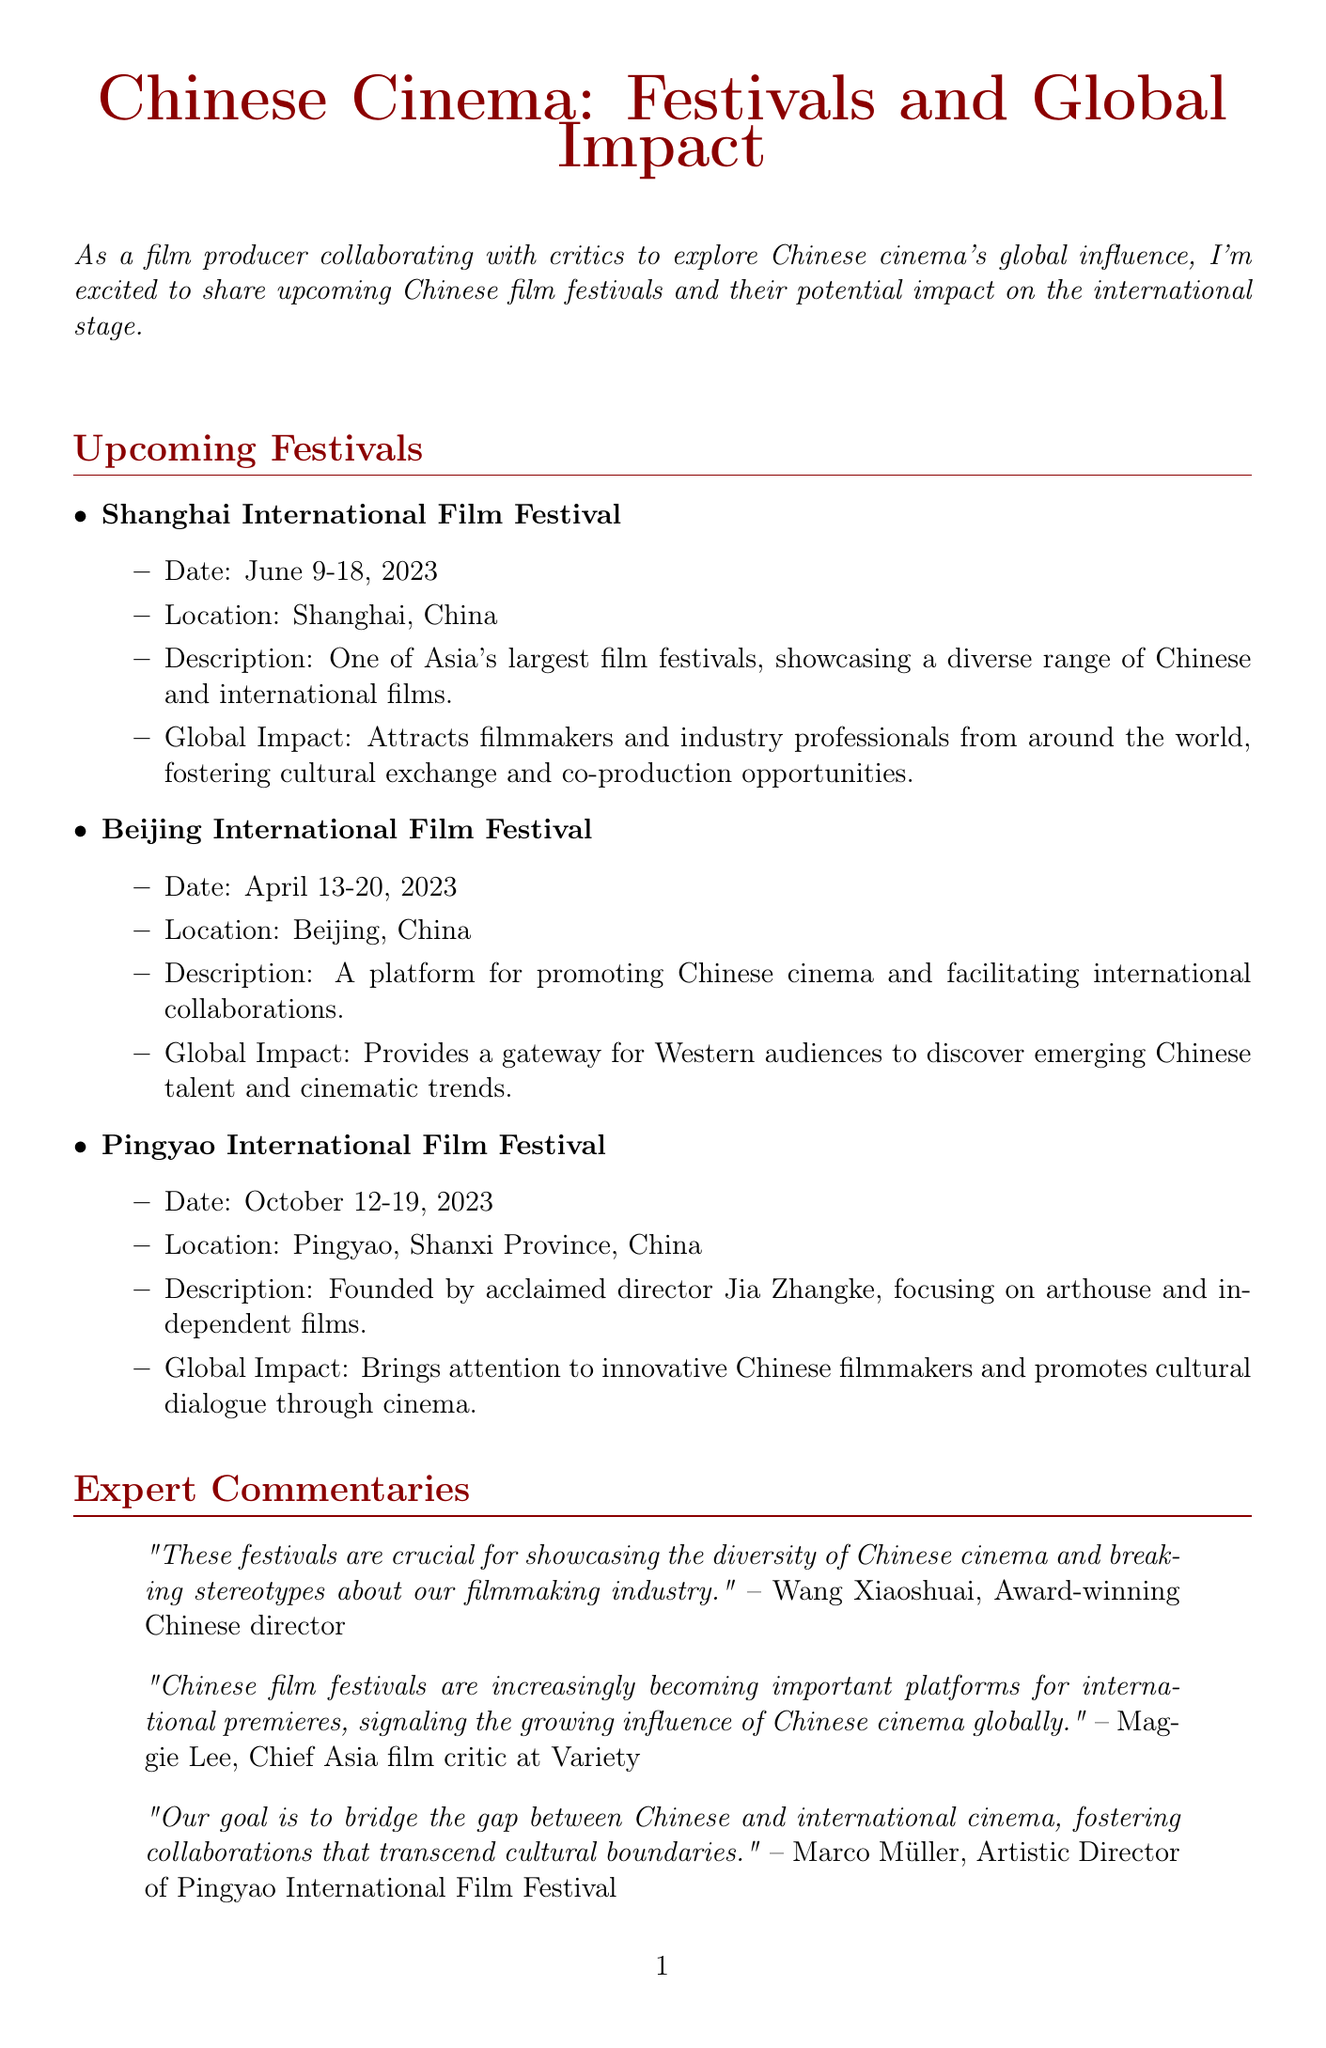What is the name of the festival held in June? The festival held in June is the Shanghai International Film Festival.
Answer: Shanghai International Film Festival What are the dates of the Pingyao International Film Festival? The dates of the Pingyao International Film Festival are October 12-19, 2023.
Answer: October 12-19, 2023 Who is the Chief Asia film critic at Variety? The Chief Asia film critic at Variety is Maggie Lee.
Answer: Maggie Lee What is the main focus of the Pingyao International Film Festival? The main focus of the Pingyao International Film Festival is arthouse and independent films.
Answer: Arthouse and independent films Which festival is described as a platform for promoting Chinese cinema? The festival described as a platform for promoting Chinese cinema is the Beijing International Film Festival.
Answer: Beijing International Film Festival What type of opportunities do these festivals provide for international producers? These festivals provide co-production opportunities for international producers.
Answer: Co-production opportunities Who founded the Pingyao International Film Festival? The Pingyao International Film Festival was founded by acclaimed director Jia Zhangke.
Answer: Jia Zhangke What common theme is highlighted by the expert commentaries? The common theme highlighted is the importance of cultural exchange and collaboration.
Answer: Cultural exchange and collaboration 